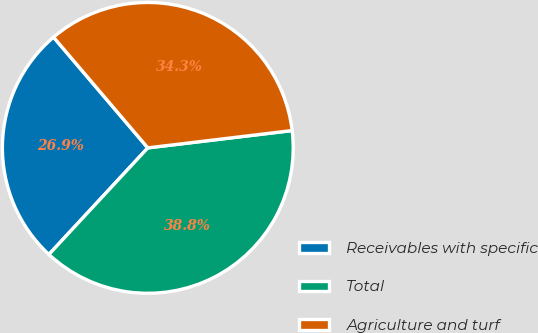<chart> <loc_0><loc_0><loc_500><loc_500><pie_chart><fcel>Receivables with specific<fcel>Total<fcel>Agriculture and turf<nl><fcel>26.87%<fcel>38.81%<fcel>34.33%<nl></chart> 